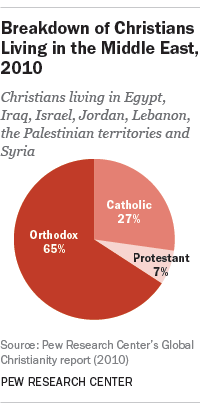Identify some key points in this picture. In the 16th century, the percentage of Catholics was higher than that of Protestants. The section that had the highest percentage was Orthodox. 